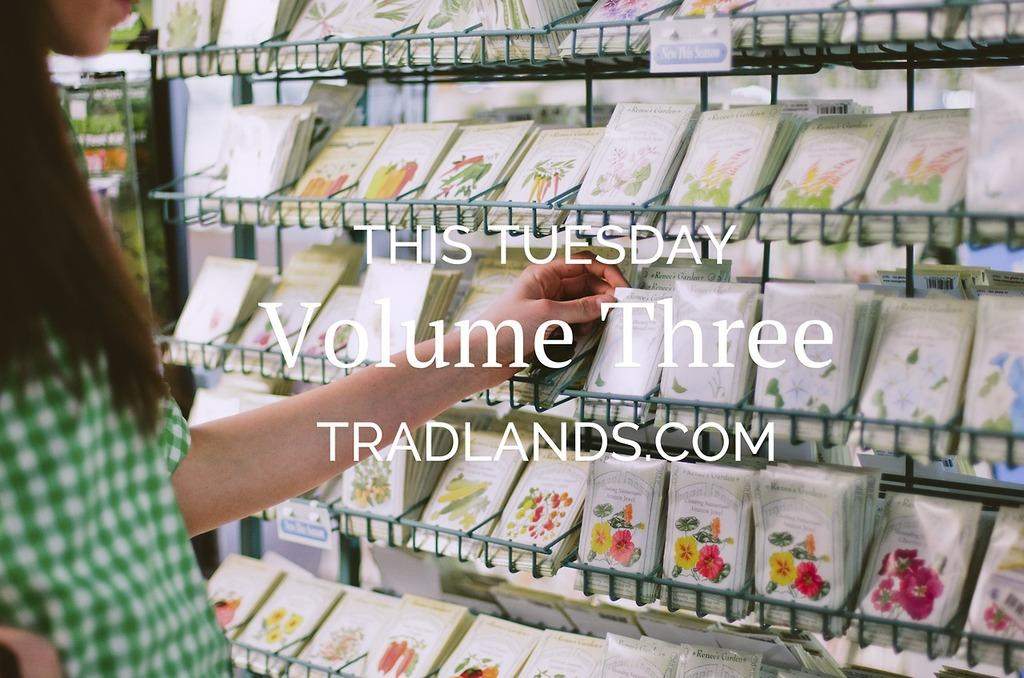Provide a one-sentence caption for the provided image. Volume Three, This Tuesday, Tradlands.com is captioned over this photo. 